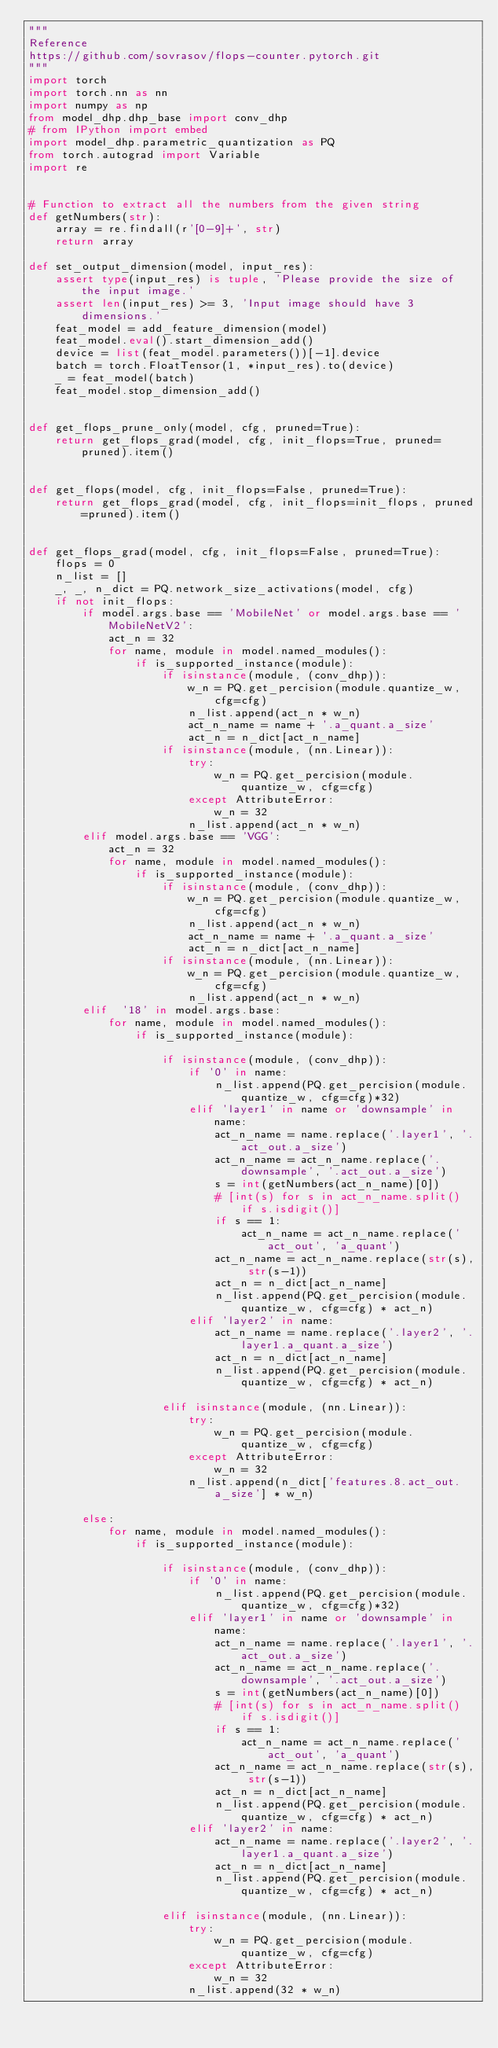<code> <loc_0><loc_0><loc_500><loc_500><_Python_>"""
Reference
https://github.com/sovrasov/flops-counter.pytorch.git
"""
import torch
import torch.nn as nn
import numpy as np
from model_dhp.dhp_base import conv_dhp
# from IPython import embed
import model_dhp.parametric_quantization as PQ
from torch.autograd import Variable
import re


# Function to extract all the numbers from the given string
def getNumbers(str):
    array = re.findall(r'[0-9]+', str)
    return array

def set_output_dimension(model, input_res):
    assert type(input_res) is tuple, 'Please provide the size of the input image.'
    assert len(input_res) >= 3, 'Input image should have 3 dimensions.'
    feat_model = add_feature_dimension(model)
    feat_model.eval().start_dimension_add()
    device = list(feat_model.parameters())[-1].device
    batch = torch.FloatTensor(1, *input_res).to(device)
    _ = feat_model(batch)
    feat_model.stop_dimension_add()


def get_flops_prune_only(model, cfg, pruned=True):
    return get_flops_grad(model, cfg, init_flops=True, pruned=pruned).item()


def get_flops(model, cfg, init_flops=False, pruned=True):
    return get_flops_grad(model, cfg, init_flops=init_flops, pruned=pruned).item()


def get_flops_grad(model, cfg, init_flops=False, pruned=True):
    flops = 0
    n_list = []
    _, _, n_dict = PQ.network_size_activations(model, cfg)
    if not init_flops:
        if model.args.base == 'MobileNet' or model.args.base == 'MobileNetV2':
            act_n = 32
            for name, module in model.named_modules():
                if is_supported_instance(module):
                    if isinstance(module, (conv_dhp)):
                        w_n = PQ.get_percision(module.quantize_w, cfg=cfg)
                        n_list.append(act_n * w_n)
                        act_n_name = name + '.a_quant.a_size'
                        act_n = n_dict[act_n_name]
                    if isinstance(module, (nn.Linear)):
                        try:
                            w_n = PQ.get_percision(module.quantize_w, cfg=cfg)
                        except AttributeError:
                            w_n = 32
                        n_list.append(act_n * w_n)
        elif model.args.base == 'VGG':
            act_n = 32
            for name, module in model.named_modules():
                if is_supported_instance(module):
                    if isinstance(module, (conv_dhp)):
                        w_n = PQ.get_percision(module.quantize_w, cfg=cfg)
                        n_list.append(act_n * w_n)
                        act_n_name = name + '.a_quant.a_size'
                        act_n = n_dict[act_n_name]
                    if isinstance(module, (nn.Linear)):
                        w_n = PQ.get_percision(module.quantize_w, cfg=cfg)
                        n_list.append(act_n * w_n)
        elif  '18' in model.args.base:
            for name, module in model.named_modules():
                if is_supported_instance(module):

                    if isinstance(module, (conv_dhp)):
                        if '0' in name:
                            n_list.append(PQ.get_percision(module.quantize_w, cfg=cfg)*32)
                        elif 'layer1' in name or 'downsample' in name:
                            act_n_name = name.replace('.layer1', '.act_out.a_size')
                            act_n_name = act_n_name.replace('.downsample', '.act_out.a_size')
                            s = int(getNumbers(act_n_name)[0])
                            # [int(s) for s in act_n_name.split() if s.isdigit()]
                            if s == 1:
                                act_n_name = act_n_name.replace('act_out', 'a_quant')
                            act_n_name = act_n_name.replace(str(s), str(s-1))
                            act_n = n_dict[act_n_name]
                            n_list.append(PQ.get_percision(module.quantize_w, cfg=cfg) * act_n)
                        elif 'layer2' in name:
                            act_n_name = name.replace('.layer2', '.layer1.a_quant.a_size')
                            act_n = n_dict[act_n_name]
                            n_list.append(PQ.get_percision(module.quantize_w, cfg=cfg) * act_n)

                    elif isinstance(module, (nn.Linear)):
                        try:
                            w_n = PQ.get_percision(module.quantize_w, cfg=cfg)
                        except AttributeError:
                            w_n = 32
                        n_list.append(n_dict['features.8.act_out.a_size'] * w_n)

        else:
            for name, module in model.named_modules():
                if is_supported_instance(module):

                    if isinstance(module, (conv_dhp)):
                        if '0' in name:
                            n_list.append(PQ.get_percision(module.quantize_w, cfg=cfg)*32)
                        elif 'layer1' in name or 'downsample' in name:
                            act_n_name = name.replace('.layer1', '.act_out.a_size')
                            act_n_name = act_n_name.replace('.downsample', '.act_out.a_size')
                            s = int(getNumbers(act_n_name)[0])
                            # [int(s) for s in act_n_name.split() if s.isdigit()]
                            if s == 1:
                                act_n_name = act_n_name.replace('act_out', 'a_quant')
                            act_n_name = act_n_name.replace(str(s), str(s-1))
                            act_n = n_dict[act_n_name]
                            n_list.append(PQ.get_percision(module.quantize_w, cfg=cfg) * act_n)
                        elif 'layer2' in name:
                            act_n_name = name.replace('.layer2', '.layer1.a_quant.a_size')
                            act_n = n_dict[act_n_name]
                            n_list.append(PQ.get_percision(module.quantize_w, cfg=cfg) * act_n)

                    elif isinstance(module, (nn.Linear)):
                        try:
                            w_n = PQ.get_percision(module.quantize_w, cfg=cfg)
                        except AttributeError:
                            w_n = 32
                        n_list.append(32 * w_n)</code> 